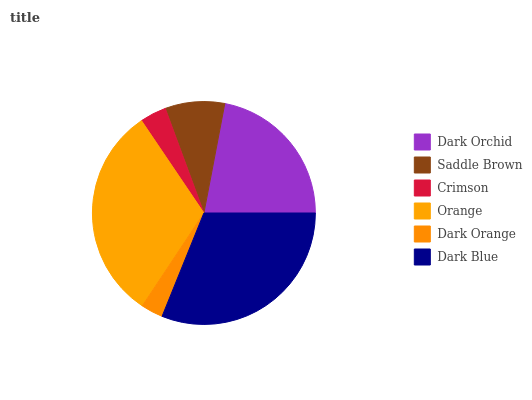Is Dark Orange the minimum?
Answer yes or no. Yes. Is Orange the maximum?
Answer yes or no. Yes. Is Saddle Brown the minimum?
Answer yes or no. No. Is Saddle Brown the maximum?
Answer yes or no. No. Is Dark Orchid greater than Saddle Brown?
Answer yes or no. Yes. Is Saddle Brown less than Dark Orchid?
Answer yes or no. Yes. Is Saddle Brown greater than Dark Orchid?
Answer yes or no. No. Is Dark Orchid less than Saddle Brown?
Answer yes or no. No. Is Dark Orchid the high median?
Answer yes or no. Yes. Is Saddle Brown the low median?
Answer yes or no. Yes. Is Orange the high median?
Answer yes or no. No. Is Dark Blue the low median?
Answer yes or no. No. 